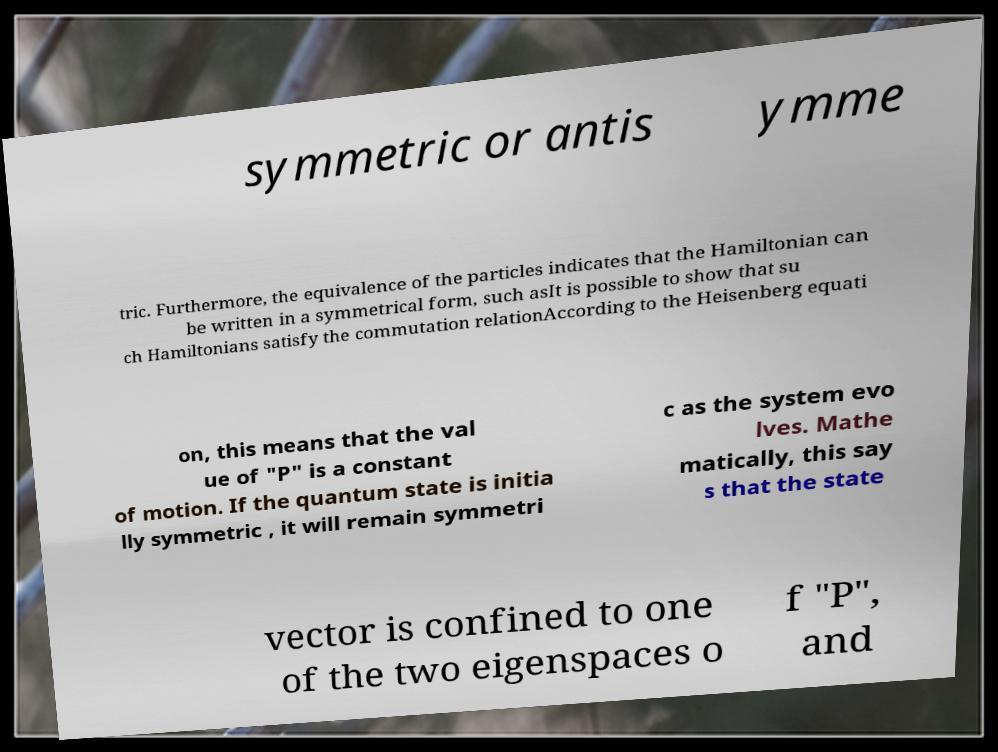What messages or text are displayed in this image? I need them in a readable, typed format. symmetric or antis ymme tric. Furthermore, the equivalence of the particles indicates that the Hamiltonian can be written in a symmetrical form, such asIt is possible to show that su ch Hamiltonians satisfy the commutation relationAccording to the Heisenberg equati on, this means that the val ue of "P" is a constant of motion. If the quantum state is initia lly symmetric , it will remain symmetri c as the system evo lves. Mathe matically, this say s that the state vector is confined to one of the two eigenspaces o f "P", and 